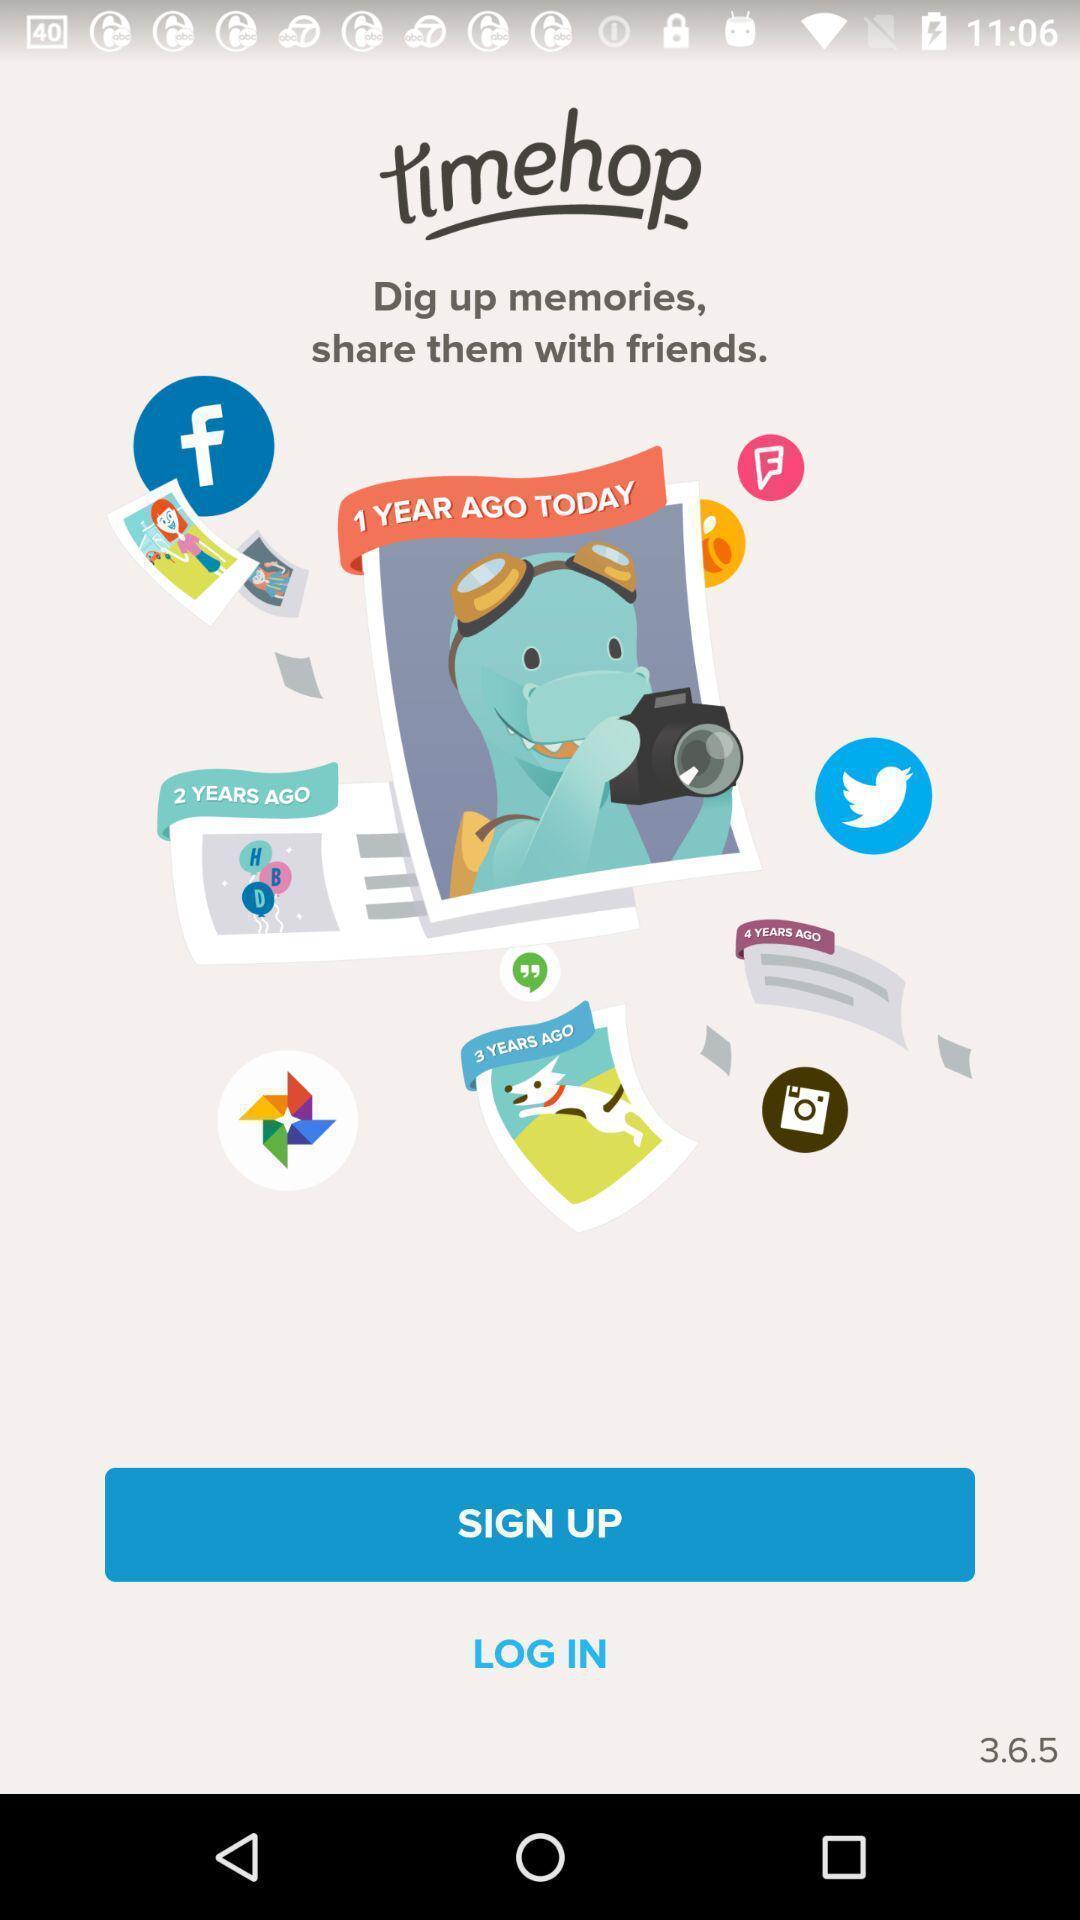Summarize the main components in this picture. Sign up page of an photo storage app. 